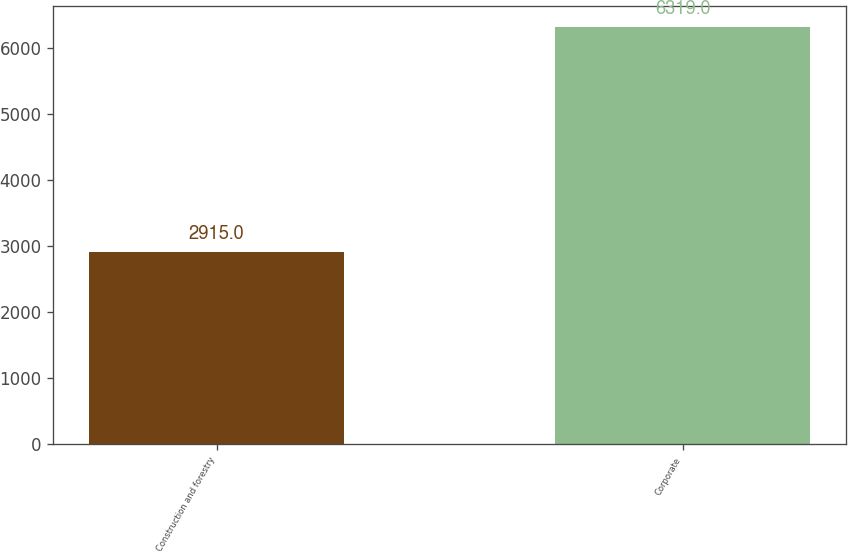Convert chart to OTSL. <chart><loc_0><loc_0><loc_500><loc_500><bar_chart><fcel>Construction and forestry<fcel>Corporate<nl><fcel>2915<fcel>6319<nl></chart> 